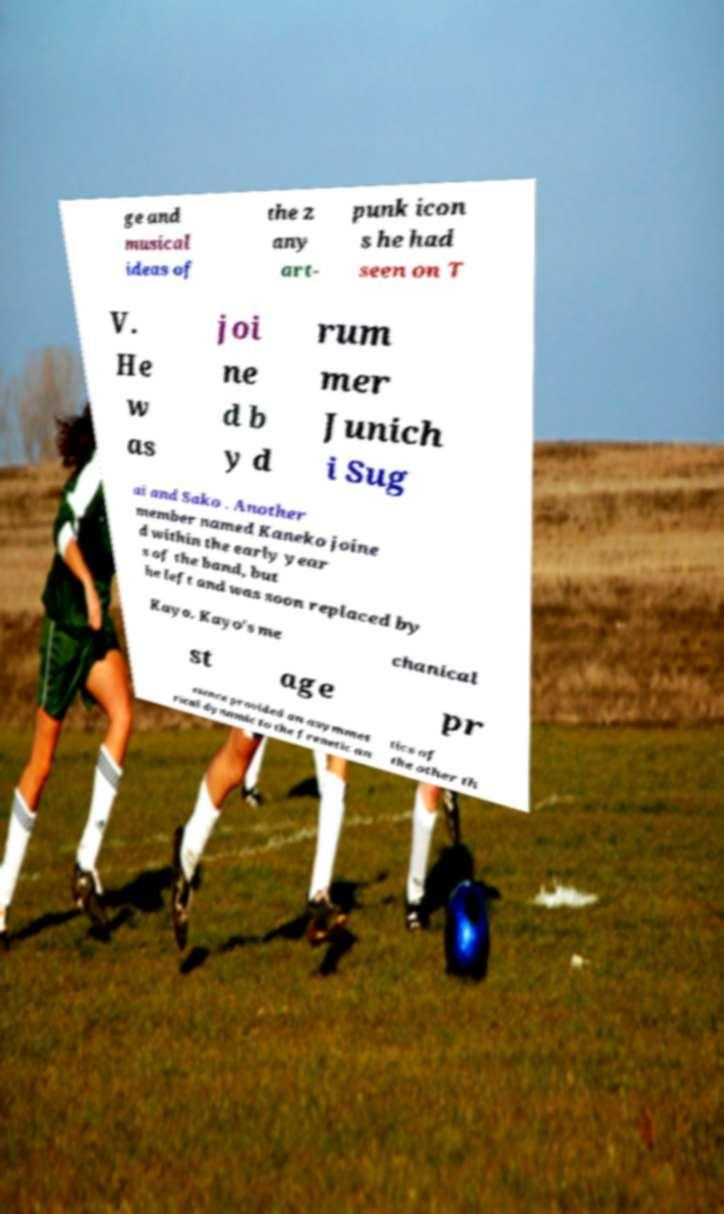There's text embedded in this image that I need extracted. Can you transcribe it verbatim? ge and musical ideas of the z any art- punk icon s he had seen on T V. He w as joi ne d b y d rum mer Junich i Sug ai and Sako . Another member named Kaneko joine d within the early year s of the band, but he left and was soon replaced by Kayo. Kayo's me chanical st age pr esence provided an asymmet rical dynamic to the frenetic an tics of the other th 